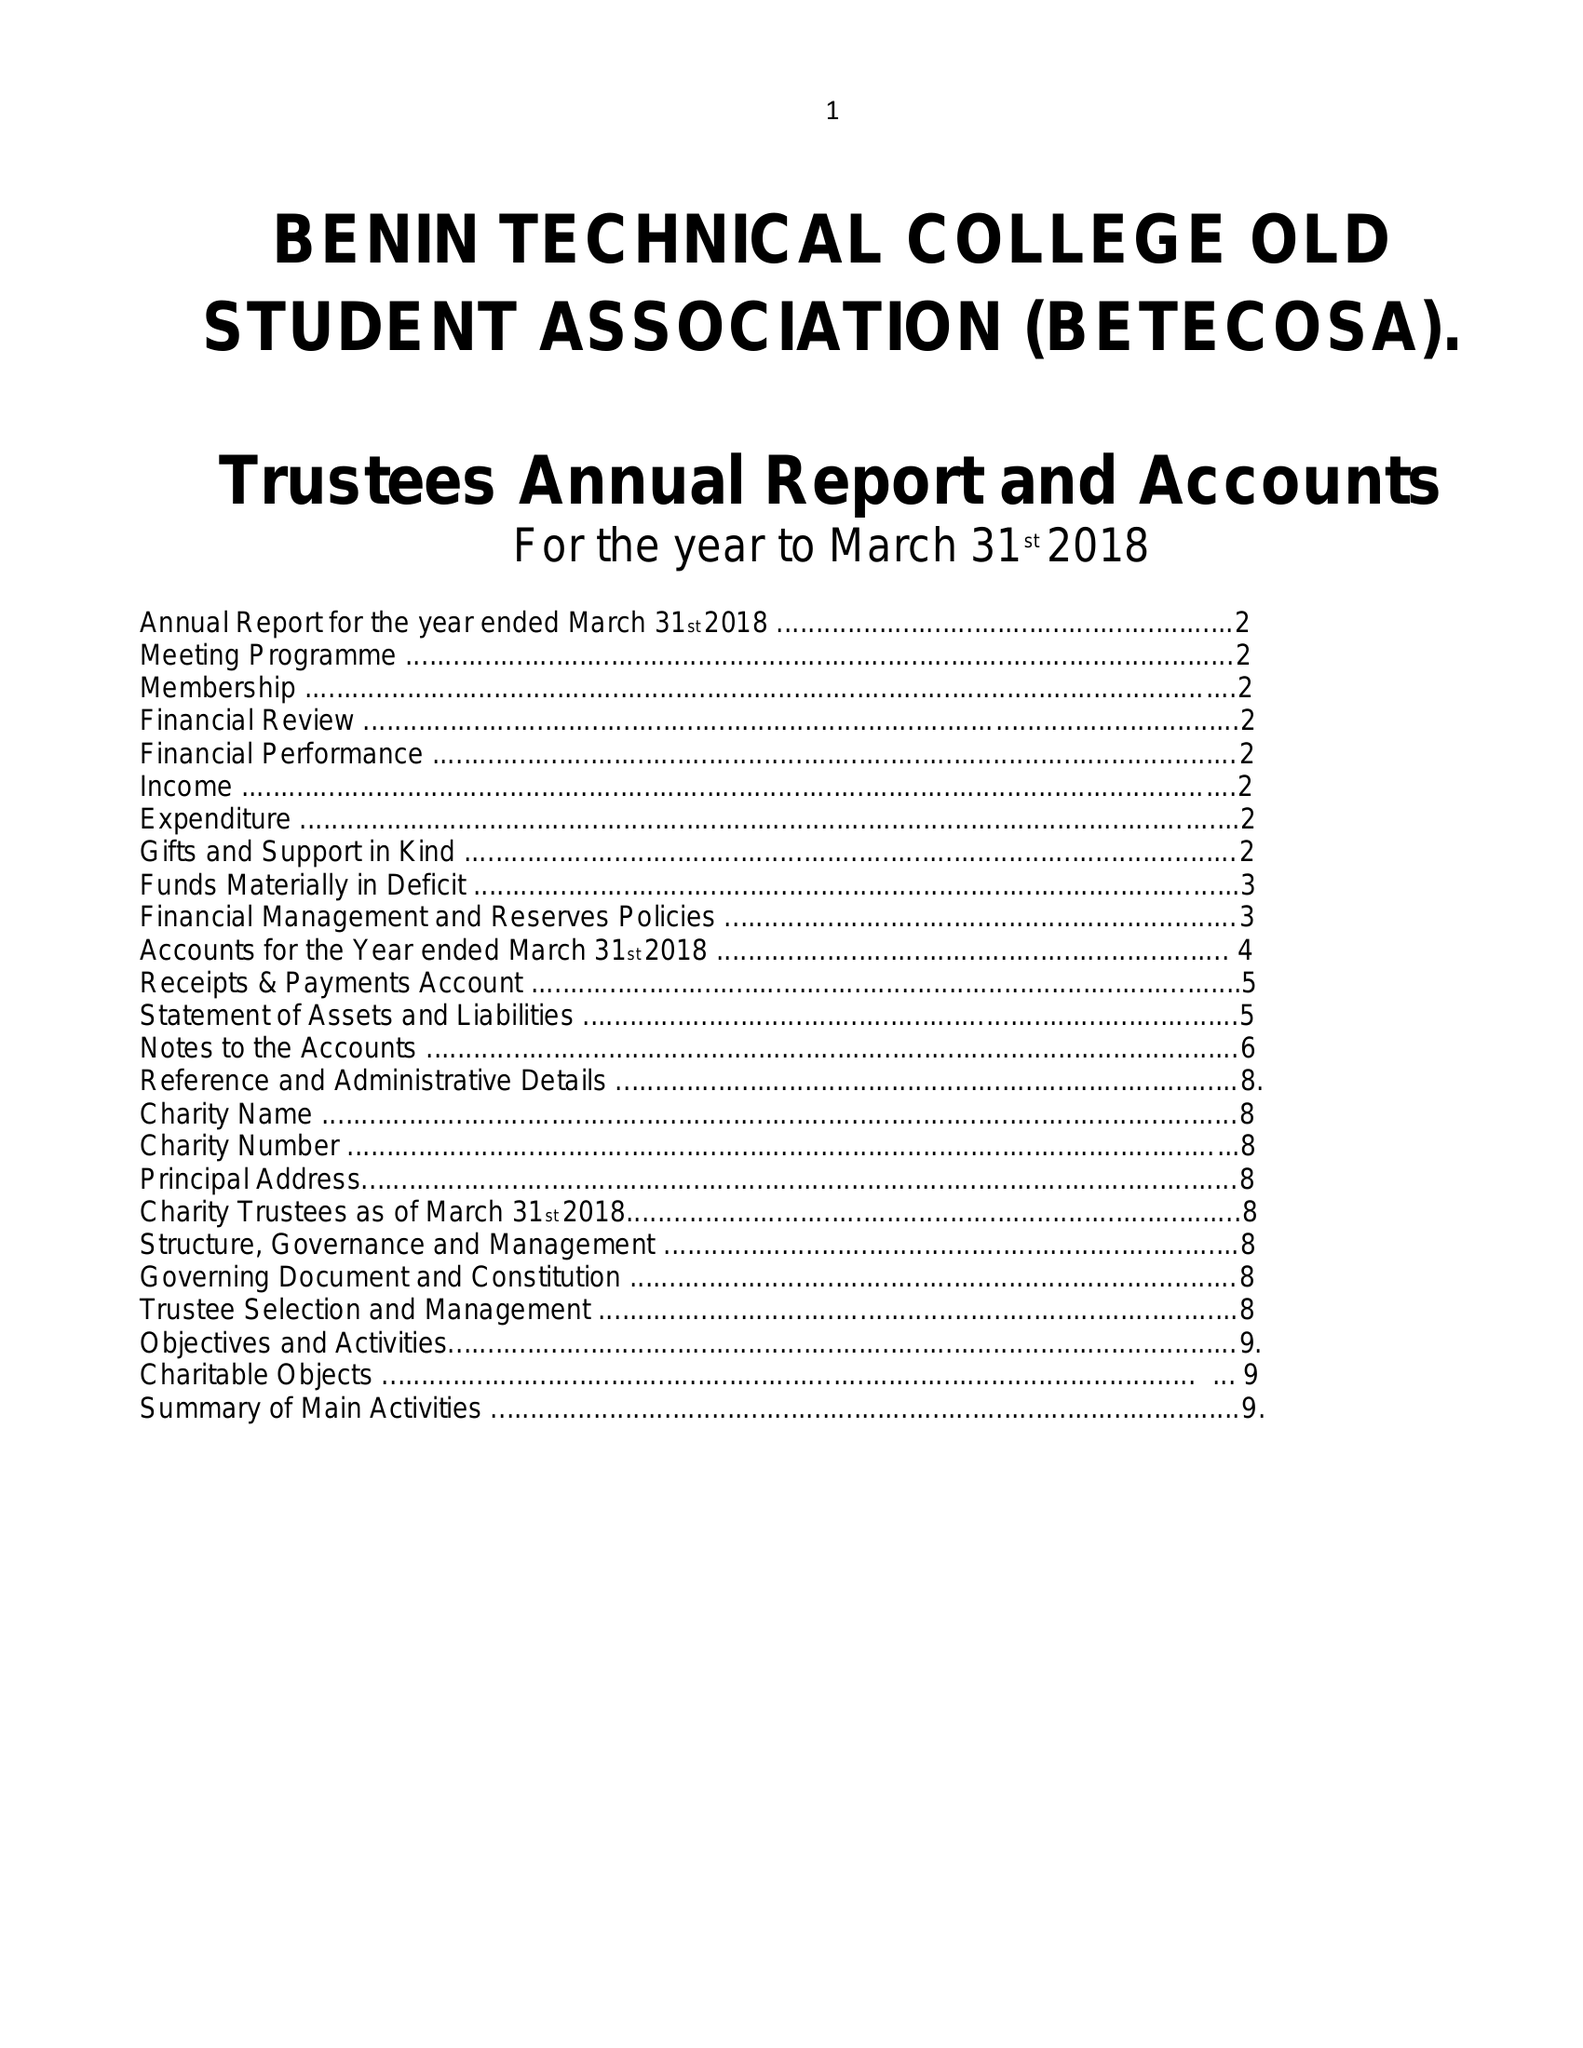What is the value for the charity_number?
Answer the question using a single word or phrase. 1170287 